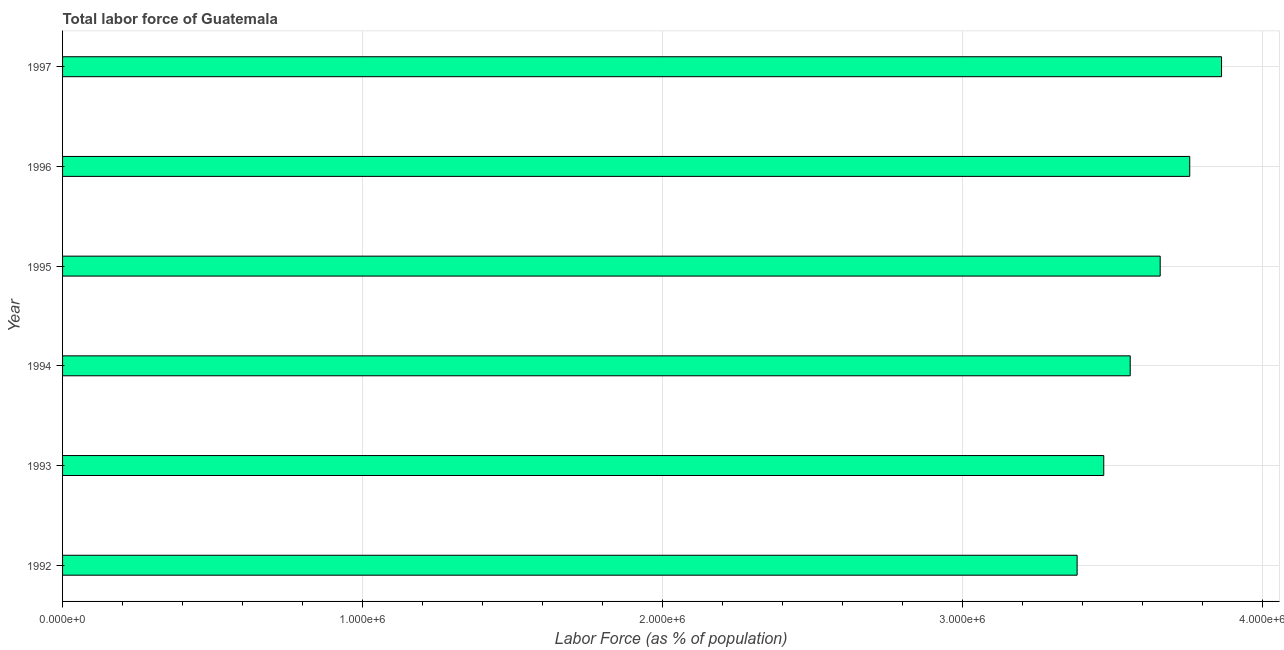What is the title of the graph?
Your response must be concise. Total labor force of Guatemala. What is the label or title of the X-axis?
Give a very brief answer. Labor Force (as % of population). What is the total labor force in 1992?
Keep it short and to the point. 3.38e+06. Across all years, what is the maximum total labor force?
Your response must be concise. 3.86e+06. Across all years, what is the minimum total labor force?
Your response must be concise. 3.38e+06. In which year was the total labor force maximum?
Your response must be concise. 1997. What is the sum of the total labor force?
Give a very brief answer. 2.17e+07. What is the difference between the total labor force in 1994 and 1997?
Your answer should be very brief. -3.04e+05. What is the average total labor force per year?
Your answer should be very brief. 3.61e+06. What is the median total labor force?
Ensure brevity in your answer.  3.61e+06. In how many years, is the total labor force greater than 200000 %?
Ensure brevity in your answer.  6. Do a majority of the years between 1993 and 1995 (inclusive) have total labor force greater than 2200000 %?
Offer a very short reply. Yes. Is the total labor force in 1993 less than that in 1995?
Your answer should be very brief. Yes. Is the difference between the total labor force in 1992 and 1994 greater than the difference between any two years?
Provide a short and direct response. No. What is the difference between the highest and the second highest total labor force?
Ensure brevity in your answer.  1.06e+05. What is the difference between the highest and the lowest total labor force?
Your answer should be very brief. 4.81e+05. How many bars are there?
Make the answer very short. 6. How many years are there in the graph?
Give a very brief answer. 6. What is the difference between two consecutive major ticks on the X-axis?
Your answer should be very brief. 1.00e+06. Are the values on the major ticks of X-axis written in scientific E-notation?
Your response must be concise. Yes. What is the Labor Force (as % of population) in 1992?
Make the answer very short. 3.38e+06. What is the Labor Force (as % of population) of 1993?
Provide a succinct answer. 3.47e+06. What is the Labor Force (as % of population) in 1994?
Ensure brevity in your answer.  3.56e+06. What is the Labor Force (as % of population) in 1995?
Make the answer very short. 3.66e+06. What is the Labor Force (as % of population) in 1996?
Offer a terse response. 3.76e+06. What is the Labor Force (as % of population) in 1997?
Your answer should be compact. 3.86e+06. What is the difference between the Labor Force (as % of population) in 1992 and 1993?
Ensure brevity in your answer.  -8.88e+04. What is the difference between the Labor Force (as % of population) in 1992 and 1994?
Your response must be concise. -1.77e+05. What is the difference between the Labor Force (as % of population) in 1992 and 1995?
Make the answer very short. -2.77e+05. What is the difference between the Labor Force (as % of population) in 1992 and 1996?
Your answer should be compact. -3.75e+05. What is the difference between the Labor Force (as % of population) in 1992 and 1997?
Provide a succinct answer. -4.81e+05. What is the difference between the Labor Force (as % of population) in 1993 and 1994?
Give a very brief answer. -8.82e+04. What is the difference between the Labor Force (as % of population) in 1993 and 1995?
Ensure brevity in your answer.  -1.88e+05. What is the difference between the Labor Force (as % of population) in 1993 and 1996?
Keep it short and to the point. -2.87e+05. What is the difference between the Labor Force (as % of population) in 1993 and 1997?
Make the answer very short. -3.93e+05. What is the difference between the Labor Force (as % of population) in 1994 and 1995?
Give a very brief answer. -9.99e+04. What is the difference between the Labor Force (as % of population) in 1994 and 1996?
Provide a short and direct response. -1.98e+05. What is the difference between the Labor Force (as % of population) in 1994 and 1997?
Offer a terse response. -3.04e+05. What is the difference between the Labor Force (as % of population) in 1995 and 1996?
Make the answer very short. -9.85e+04. What is the difference between the Labor Force (as % of population) in 1995 and 1997?
Offer a terse response. -2.04e+05. What is the difference between the Labor Force (as % of population) in 1996 and 1997?
Provide a short and direct response. -1.06e+05. What is the ratio of the Labor Force (as % of population) in 1992 to that in 1993?
Offer a very short reply. 0.97. What is the ratio of the Labor Force (as % of population) in 1992 to that in 1994?
Ensure brevity in your answer.  0.95. What is the ratio of the Labor Force (as % of population) in 1992 to that in 1995?
Ensure brevity in your answer.  0.92. What is the ratio of the Labor Force (as % of population) in 1992 to that in 1996?
Give a very brief answer. 0.9. What is the ratio of the Labor Force (as % of population) in 1992 to that in 1997?
Provide a succinct answer. 0.88. What is the ratio of the Labor Force (as % of population) in 1993 to that in 1994?
Offer a very short reply. 0.97. What is the ratio of the Labor Force (as % of population) in 1993 to that in 1995?
Your response must be concise. 0.95. What is the ratio of the Labor Force (as % of population) in 1993 to that in 1996?
Your response must be concise. 0.92. What is the ratio of the Labor Force (as % of population) in 1993 to that in 1997?
Offer a very short reply. 0.9. What is the ratio of the Labor Force (as % of population) in 1994 to that in 1996?
Offer a terse response. 0.95. What is the ratio of the Labor Force (as % of population) in 1994 to that in 1997?
Make the answer very short. 0.92. What is the ratio of the Labor Force (as % of population) in 1995 to that in 1996?
Keep it short and to the point. 0.97. What is the ratio of the Labor Force (as % of population) in 1995 to that in 1997?
Make the answer very short. 0.95. 